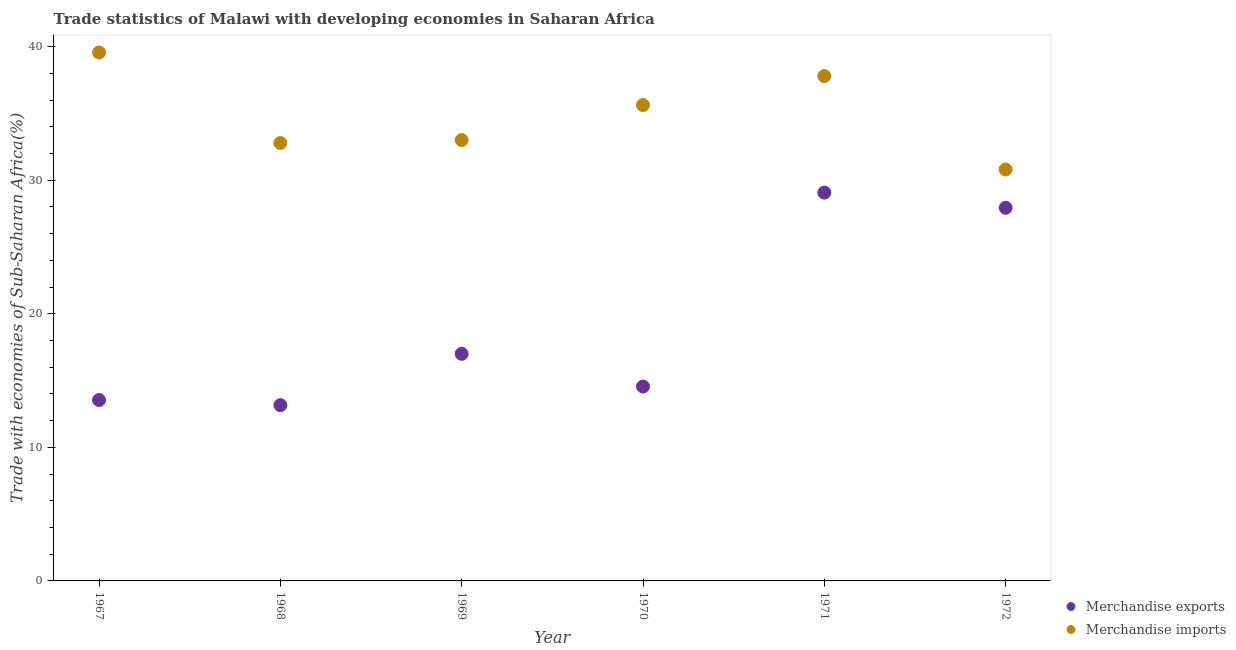Is the number of dotlines equal to the number of legend labels?
Offer a very short reply. Yes. What is the merchandise imports in 1971?
Ensure brevity in your answer.  37.79. Across all years, what is the maximum merchandise imports?
Ensure brevity in your answer.  39.56. Across all years, what is the minimum merchandise exports?
Provide a short and direct response. 13.16. In which year was the merchandise exports maximum?
Your answer should be compact. 1971. In which year was the merchandise imports minimum?
Keep it short and to the point. 1972. What is the total merchandise imports in the graph?
Your answer should be compact. 209.55. What is the difference between the merchandise imports in 1969 and that in 1972?
Keep it short and to the point. 2.2. What is the difference between the merchandise imports in 1972 and the merchandise exports in 1971?
Give a very brief answer. 1.73. What is the average merchandise exports per year?
Provide a short and direct response. 19.21. In the year 1967, what is the difference between the merchandise exports and merchandise imports?
Offer a very short reply. -26.02. In how many years, is the merchandise imports greater than 36 %?
Ensure brevity in your answer.  2. What is the ratio of the merchandise exports in 1968 to that in 1969?
Provide a short and direct response. 0.77. What is the difference between the highest and the second highest merchandise exports?
Give a very brief answer. 1.14. What is the difference between the highest and the lowest merchandise exports?
Give a very brief answer. 15.91. Is the sum of the merchandise imports in 1967 and 1969 greater than the maximum merchandise exports across all years?
Make the answer very short. Yes. How many dotlines are there?
Offer a very short reply. 2. Are the values on the major ticks of Y-axis written in scientific E-notation?
Offer a terse response. No. Where does the legend appear in the graph?
Your response must be concise. Bottom right. What is the title of the graph?
Your response must be concise. Trade statistics of Malawi with developing economies in Saharan Africa. Does "Transport services" appear as one of the legend labels in the graph?
Your answer should be compact. No. What is the label or title of the X-axis?
Offer a terse response. Year. What is the label or title of the Y-axis?
Your answer should be very brief. Trade with economies of Sub-Saharan Africa(%). What is the Trade with economies of Sub-Saharan Africa(%) in Merchandise exports in 1967?
Your answer should be compact. 13.54. What is the Trade with economies of Sub-Saharan Africa(%) in Merchandise imports in 1967?
Make the answer very short. 39.56. What is the Trade with economies of Sub-Saharan Africa(%) in Merchandise exports in 1968?
Offer a terse response. 13.16. What is the Trade with economies of Sub-Saharan Africa(%) of Merchandise imports in 1968?
Your response must be concise. 32.78. What is the Trade with economies of Sub-Saharan Africa(%) of Merchandise exports in 1969?
Your answer should be compact. 17. What is the Trade with economies of Sub-Saharan Africa(%) of Merchandise imports in 1969?
Offer a very short reply. 33. What is the Trade with economies of Sub-Saharan Africa(%) of Merchandise exports in 1970?
Keep it short and to the point. 14.55. What is the Trade with economies of Sub-Saharan Africa(%) of Merchandise imports in 1970?
Make the answer very short. 35.62. What is the Trade with economies of Sub-Saharan Africa(%) in Merchandise exports in 1971?
Your answer should be very brief. 29.07. What is the Trade with economies of Sub-Saharan Africa(%) of Merchandise imports in 1971?
Keep it short and to the point. 37.79. What is the Trade with economies of Sub-Saharan Africa(%) in Merchandise exports in 1972?
Your answer should be compact. 27.93. What is the Trade with economies of Sub-Saharan Africa(%) of Merchandise imports in 1972?
Keep it short and to the point. 30.8. Across all years, what is the maximum Trade with economies of Sub-Saharan Africa(%) of Merchandise exports?
Your response must be concise. 29.07. Across all years, what is the maximum Trade with economies of Sub-Saharan Africa(%) in Merchandise imports?
Give a very brief answer. 39.56. Across all years, what is the minimum Trade with economies of Sub-Saharan Africa(%) in Merchandise exports?
Ensure brevity in your answer.  13.16. Across all years, what is the minimum Trade with economies of Sub-Saharan Africa(%) of Merchandise imports?
Keep it short and to the point. 30.8. What is the total Trade with economies of Sub-Saharan Africa(%) in Merchandise exports in the graph?
Provide a short and direct response. 115.25. What is the total Trade with economies of Sub-Saharan Africa(%) of Merchandise imports in the graph?
Your answer should be compact. 209.55. What is the difference between the Trade with economies of Sub-Saharan Africa(%) in Merchandise exports in 1967 and that in 1968?
Your answer should be compact. 0.38. What is the difference between the Trade with economies of Sub-Saharan Africa(%) of Merchandise imports in 1967 and that in 1968?
Keep it short and to the point. 6.77. What is the difference between the Trade with economies of Sub-Saharan Africa(%) of Merchandise exports in 1967 and that in 1969?
Offer a very short reply. -3.46. What is the difference between the Trade with economies of Sub-Saharan Africa(%) of Merchandise imports in 1967 and that in 1969?
Your answer should be compact. 6.55. What is the difference between the Trade with economies of Sub-Saharan Africa(%) in Merchandise exports in 1967 and that in 1970?
Give a very brief answer. -1.01. What is the difference between the Trade with economies of Sub-Saharan Africa(%) in Merchandise imports in 1967 and that in 1970?
Offer a very short reply. 3.93. What is the difference between the Trade with economies of Sub-Saharan Africa(%) in Merchandise exports in 1967 and that in 1971?
Give a very brief answer. -15.53. What is the difference between the Trade with economies of Sub-Saharan Africa(%) of Merchandise imports in 1967 and that in 1971?
Provide a succinct answer. 1.77. What is the difference between the Trade with economies of Sub-Saharan Africa(%) of Merchandise exports in 1967 and that in 1972?
Ensure brevity in your answer.  -14.39. What is the difference between the Trade with economies of Sub-Saharan Africa(%) of Merchandise imports in 1967 and that in 1972?
Give a very brief answer. 8.76. What is the difference between the Trade with economies of Sub-Saharan Africa(%) of Merchandise exports in 1968 and that in 1969?
Provide a succinct answer. -3.84. What is the difference between the Trade with economies of Sub-Saharan Africa(%) of Merchandise imports in 1968 and that in 1969?
Provide a short and direct response. -0.22. What is the difference between the Trade with economies of Sub-Saharan Africa(%) in Merchandise exports in 1968 and that in 1970?
Your answer should be very brief. -1.39. What is the difference between the Trade with economies of Sub-Saharan Africa(%) in Merchandise imports in 1968 and that in 1970?
Keep it short and to the point. -2.84. What is the difference between the Trade with economies of Sub-Saharan Africa(%) of Merchandise exports in 1968 and that in 1971?
Provide a short and direct response. -15.91. What is the difference between the Trade with economies of Sub-Saharan Africa(%) in Merchandise imports in 1968 and that in 1971?
Give a very brief answer. -5.01. What is the difference between the Trade with economies of Sub-Saharan Africa(%) of Merchandise exports in 1968 and that in 1972?
Your answer should be compact. -14.77. What is the difference between the Trade with economies of Sub-Saharan Africa(%) in Merchandise imports in 1968 and that in 1972?
Give a very brief answer. 1.99. What is the difference between the Trade with economies of Sub-Saharan Africa(%) of Merchandise exports in 1969 and that in 1970?
Give a very brief answer. 2.45. What is the difference between the Trade with economies of Sub-Saharan Africa(%) in Merchandise imports in 1969 and that in 1970?
Offer a very short reply. -2.62. What is the difference between the Trade with economies of Sub-Saharan Africa(%) of Merchandise exports in 1969 and that in 1971?
Your answer should be compact. -12.07. What is the difference between the Trade with economies of Sub-Saharan Africa(%) of Merchandise imports in 1969 and that in 1971?
Offer a terse response. -4.79. What is the difference between the Trade with economies of Sub-Saharan Africa(%) in Merchandise exports in 1969 and that in 1972?
Your response must be concise. -10.93. What is the difference between the Trade with economies of Sub-Saharan Africa(%) of Merchandise imports in 1969 and that in 1972?
Offer a very short reply. 2.2. What is the difference between the Trade with economies of Sub-Saharan Africa(%) in Merchandise exports in 1970 and that in 1971?
Offer a terse response. -14.52. What is the difference between the Trade with economies of Sub-Saharan Africa(%) of Merchandise imports in 1970 and that in 1971?
Make the answer very short. -2.17. What is the difference between the Trade with economies of Sub-Saharan Africa(%) in Merchandise exports in 1970 and that in 1972?
Ensure brevity in your answer.  -13.38. What is the difference between the Trade with economies of Sub-Saharan Africa(%) in Merchandise imports in 1970 and that in 1972?
Your answer should be compact. 4.83. What is the difference between the Trade with economies of Sub-Saharan Africa(%) of Merchandise exports in 1971 and that in 1972?
Offer a terse response. 1.14. What is the difference between the Trade with economies of Sub-Saharan Africa(%) in Merchandise imports in 1971 and that in 1972?
Offer a terse response. 6.99. What is the difference between the Trade with economies of Sub-Saharan Africa(%) in Merchandise exports in 1967 and the Trade with economies of Sub-Saharan Africa(%) in Merchandise imports in 1968?
Your answer should be very brief. -19.24. What is the difference between the Trade with economies of Sub-Saharan Africa(%) in Merchandise exports in 1967 and the Trade with economies of Sub-Saharan Africa(%) in Merchandise imports in 1969?
Your response must be concise. -19.46. What is the difference between the Trade with economies of Sub-Saharan Africa(%) in Merchandise exports in 1967 and the Trade with economies of Sub-Saharan Africa(%) in Merchandise imports in 1970?
Keep it short and to the point. -22.08. What is the difference between the Trade with economies of Sub-Saharan Africa(%) in Merchandise exports in 1967 and the Trade with economies of Sub-Saharan Africa(%) in Merchandise imports in 1971?
Your answer should be compact. -24.25. What is the difference between the Trade with economies of Sub-Saharan Africa(%) of Merchandise exports in 1967 and the Trade with economies of Sub-Saharan Africa(%) of Merchandise imports in 1972?
Keep it short and to the point. -17.26. What is the difference between the Trade with economies of Sub-Saharan Africa(%) in Merchandise exports in 1968 and the Trade with economies of Sub-Saharan Africa(%) in Merchandise imports in 1969?
Provide a short and direct response. -19.84. What is the difference between the Trade with economies of Sub-Saharan Africa(%) of Merchandise exports in 1968 and the Trade with economies of Sub-Saharan Africa(%) of Merchandise imports in 1970?
Provide a succinct answer. -22.47. What is the difference between the Trade with economies of Sub-Saharan Africa(%) in Merchandise exports in 1968 and the Trade with economies of Sub-Saharan Africa(%) in Merchandise imports in 1971?
Your answer should be compact. -24.63. What is the difference between the Trade with economies of Sub-Saharan Africa(%) of Merchandise exports in 1968 and the Trade with economies of Sub-Saharan Africa(%) of Merchandise imports in 1972?
Your response must be concise. -17.64. What is the difference between the Trade with economies of Sub-Saharan Africa(%) of Merchandise exports in 1969 and the Trade with economies of Sub-Saharan Africa(%) of Merchandise imports in 1970?
Offer a very short reply. -18.62. What is the difference between the Trade with economies of Sub-Saharan Africa(%) of Merchandise exports in 1969 and the Trade with economies of Sub-Saharan Africa(%) of Merchandise imports in 1971?
Give a very brief answer. -20.79. What is the difference between the Trade with economies of Sub-Saharan Africa(%) of Merchandise exports in 1969 and the Trade with economies of Sub-Saharan Africa(%) of Merchandise imports in 1972?
Provide a short and direct response. -13.8. What is the difference between the Trade with economies of Sub-Saharan Africa(%) in Merchandise exports in 1970 and the Trade with economies of Sub-Saharan Africa(%) in Merchandise imports in 1971?
Your response must be concise. -23.24. What is the difference between the Trade with economies of Sub-Saharan Africa(%) in Merchandise exports in 1970 and the Trade with economies of Sub-Saharan Africa(%) in Merchandise imports in 1972?
Provide a short and direct response. -16.25. What is the difference between the Trade with economies of Sub-Saharan Africa(%) of Merchandise exports in 1971 and the Trade with economies of Sub-Saharan Africa(%) of Merchandise imports in 1972?
Provide a succinct answer. -1.73. What is the average Trade with economies of Sub-Saharan Africa(%) in Merchandise exports per year?
Your answer should be very brief. 19.21. What is the average Trade with economies of Sub-Saharan Africa(%) of Merchandise imports per year?
Offer a very short reply. 34.93. In the year 1967, what is the difference between the Trade with economies of Sub-Saharan Africa(%) of Merchandise exports and Trade with economies of Sub-Saharan Africa(%) of Merchandise imports?
Your response must be concise. -26.02. In the year 1968, what is the difference between the Trade with economies of Sub-Saharan Africa(%) in Merchandise exports and Trade with economies of Sub-Saharan Africa(%) in Merchandise imports?
Offer a very short reply. -19.62. In the year 1969, what is the difference between the Trade with economies of Sub-Saharan Africa(%) of Merchandise exports and Trade with economies of Sub-Saharan Africa(%) of Merchandise imports?
Your response must be concise. -16. In the year 1970, what is the difference between the Trade with economies of Sub-Saharan Africa(%) in Merchandise exports and Trade with economies of Sub-Saharan Africa(%) in Merchandise imports?
Provide a short and direct response. -21.07. In the year 1971, what is the difference between the Trade with economies of Sub-Saharan Africa(%) of Merchandise exports and Trade with economies of Sub-Saharan Africa(%) of Merchandise imports?
Your answer should be compact. -8.72. In the year 1972, what is the difference between the Trade with economies of Sub-Saharan Africa(%) of Merchandise exports and Trade with economies of Sub-Saharan Africa(%) of Merchandise imports?
Give a very brief answer. -2.87. What is the ratio of the Trade with economies of Sub-Saharan Africa(%) of Merchandise imports in 1967 to that in 1968?
Provide a succinct answer. 1.21. What is the ratio of the Trade with economies of Sub-Saharan Africa(%) of Merchandise exports in 1967 to that in 1969?
Make the answer very short. 0.8. What is the ratio of the Trade with economies of Sub-Saharan Africa(%) of Merchandise imports in 1967 to that in 1969?
Keep it short and to the point. 1.2. What is the ratio of the Trade with economies of Sub-Saharan Africa(%) in Merchandise exports in 1967 to that in 1970?
Make the answer very short. 0.93. What is the ratio of the Trade with economies of Sub-Saharan Africa(%) of Merchandise imports in 1967 to that in 1970?
Offer a very short reply. 1.11. What is the ratio of the Trade with economies of Sub-Saharan Africa(%) of Merchandise exports in 1967 to that in 1971?
Your answer should be very brief. 0.47. What is the ratio of the Trade with economies of Sub-Saharan Africa(%) of Merchandise imports in 1967 to that in 1971?
Your response must be concise. 1.05. What is the ratio of the Trade with economies of Sub-Saharan Africa(%) of Merchandise exports in 1967 to that in 1972?
Provide a short and direct response. 0.48. What is the ratio of the Trade with economies of Sub-Saharan Africa(%) of Merchandise imports in 1967 to that in 1972?
Ensure brevity in your answer.  1.28. What is the ratio of the Trade with economies of Sub-Saharan Africa(%) in Merchandise exports in 1968 to that in 1969?
Your answer should be very brief. 0.77. What is the ratio of the Trade with economies of Sub-Saharan Africa(%) in Merchandise imports in 1968 to that in 1969?
Your answer should be compact. 0.99. What is the ratio of the Trade with economies of Sub-Saharan Africa(%) of Merchandise exports in 1968 to that in 1970?
Provide a short and direct response. 0.9. What is the ratio of the Trade with economies of Sub-Saharan Africa(%) in Merchandise imports in 1968 to that in 1970?
Give a very brief answer. 0.92. What is the ratio of the Trade with economies of Sub-Saharan Africa(%) in Merchandise exports in 1968 to that in 1971?
Give a very brief answer. 0.45. What is the ratio of the Trade with economies of Sub-Saharan Africa(%) of Merchandise imports in 1968 to that in 1971?
Provide a short and direct response. 0.87. What is the ratio of the Trade with economies of Sub-Saharan Africa(%) of Merchandise exports in 1968 to that in 1972?
Your answer should be compact. 0.47. What is the ratio of the Trade with economies of Sub-Saharan Africa(%) in Merchandise imports in 1968 to that in 1972?
Make the answer very short. 1.06. What is the ratio of the Trade with economies of Sub-Saharan Africa(%) in Merchandise exports in 1969 to that in 1970?
Offer a very short reply. 1.17. What is the ratio of the Trade with economies of Sub-Saharan Africa(%) in Merchandise imports in 1969 to that in 1970?
Make the answer very short. 0.93. What is the ratio of the Trade with economies of Sub-Saharan Africa(%) of Merchandise exports in 1969 to that in 1971?
Your response must be concise. 0.58. What is the ratio of the Trade with economies of Sub-Saharan Africa(%) of Merchandise imports in 1969 to that in 1971?
Offer a terse response. 0.87. What is the ratio of the Trade with economies of Sub-Saharan Africa(%) of Merchandise exports in 1969 to that in 1972?
Your answer should be compact. 0.61. What is the ratio of the Trade with economies of Sub-Saharan Africa(%) of Merchandise imports in 1969 to that in 1972?
Provide a short and direct response. 1.07. What is the ratio of the Trade with economies of Sub-Saharan Africa(%) of Merchandise exports in 1970 to that in 1971?
Your response must be concise. 0.5. What is the ratio of the Trade with economies of Sub-Saharan Africa(%) in Merchandise imports in 1970 to that in 1971?
Your answer should be compact. 0.94. What is the ratio of the Trade with economies of Sub-Saharan Africa(%) in Merchandise exports in 1970 to that in 1972?
Offer a very short reply. 0.52. What is the ratio of the Trade with economies of Sub-Saharan Africa(%) of Merchandise imports in 1970 to that in 1972?
Ensure brevity in your answer.  1.16. What is the ratio of the Trade with economies of Sub-Saharan Africa(%) of Merchandise exports in 1971 to that in 1972?
Your answer should be very brief. 1.04. What is the ratio of the Trade with economies of Sub-Saharan Africa(%) of Merchandise imports in 1971 to that in 1972?
Your response must be concise. 1.23. What is the difference between the highest and the second highest Trade with economies of Sub-Saharan Africa(%) of Merchandise exports?
Provide a short and direct response. 1.14. What is the difference between the highest and the second highest Trade with economies of Sub-Saharan Africa(%) in Merchandise imports?
Ensure brevity in your answer.  1.77. What is the difference between the highest and the lowest Trade with economies of Sub-Saharan Africa(%) in Merchandise exports?
Your answer should be compact. 15.91. What is the difference between the highest and the lowest Trade with economies of Sub-Saharan Africa(%) of Merchandise imports?
Provide a succinct answer. 8.76. 